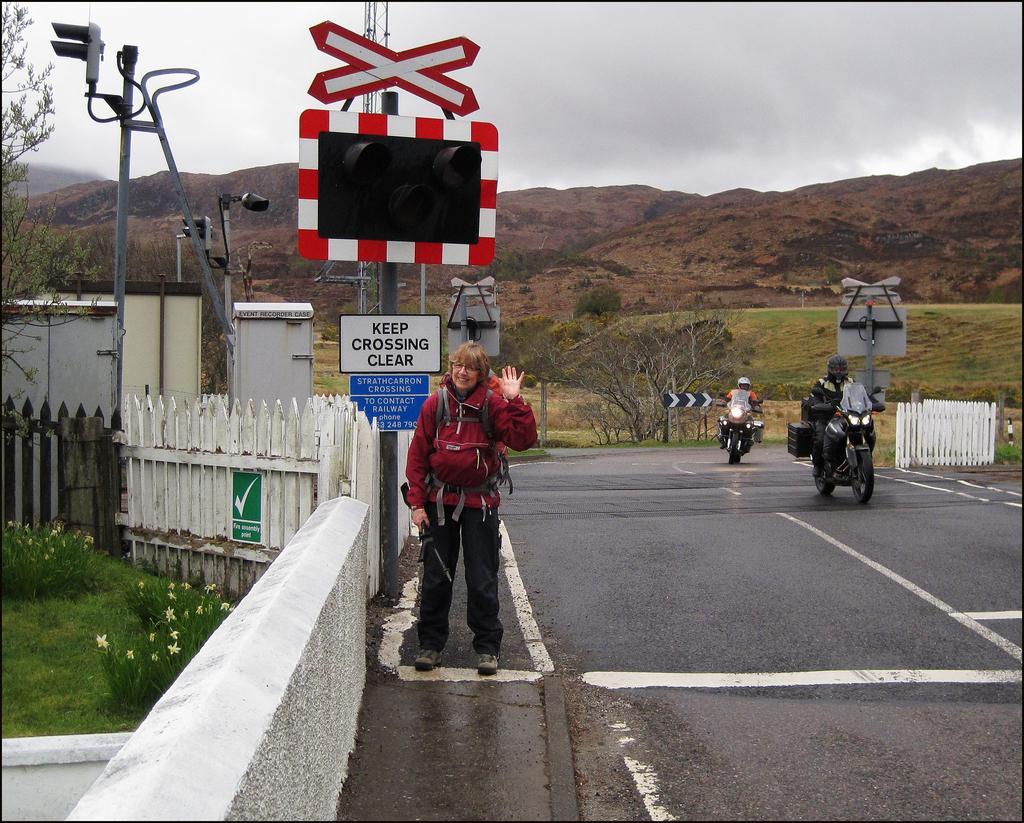Please provide a concise description of this image. In this image, we can see a few people. Among them, some people are riding motorcycles and a person holding some object is standing. We can see the ground and the fence. We can see some grass, trees, plants and hills. We can also see the sky. We can also see some metal objects and signboards. 